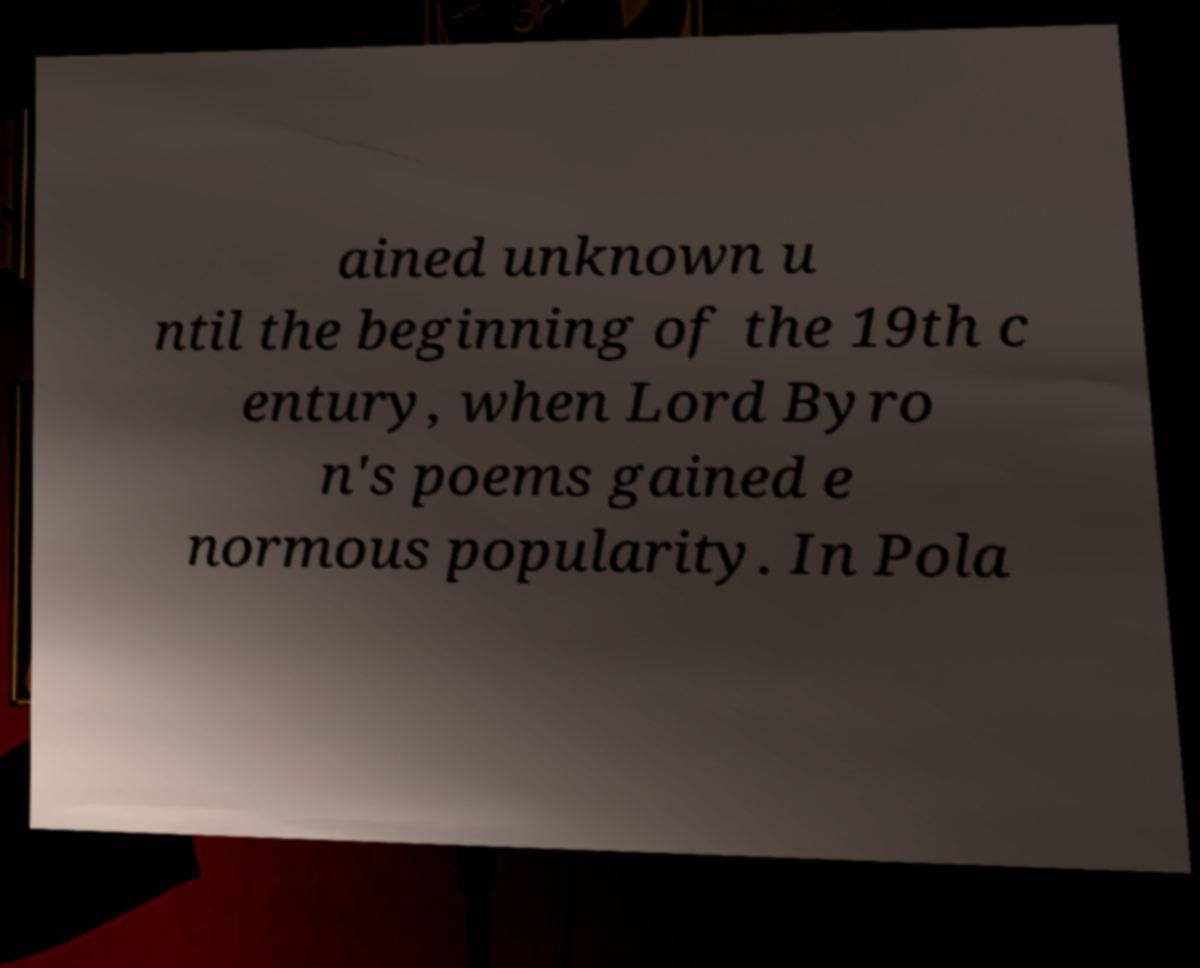Could you extract and type out the text from this image? ained unknown u ntil the beginning of the 19th c entury, when Lord Byro n's poems gained e normous popularity. In Pola 